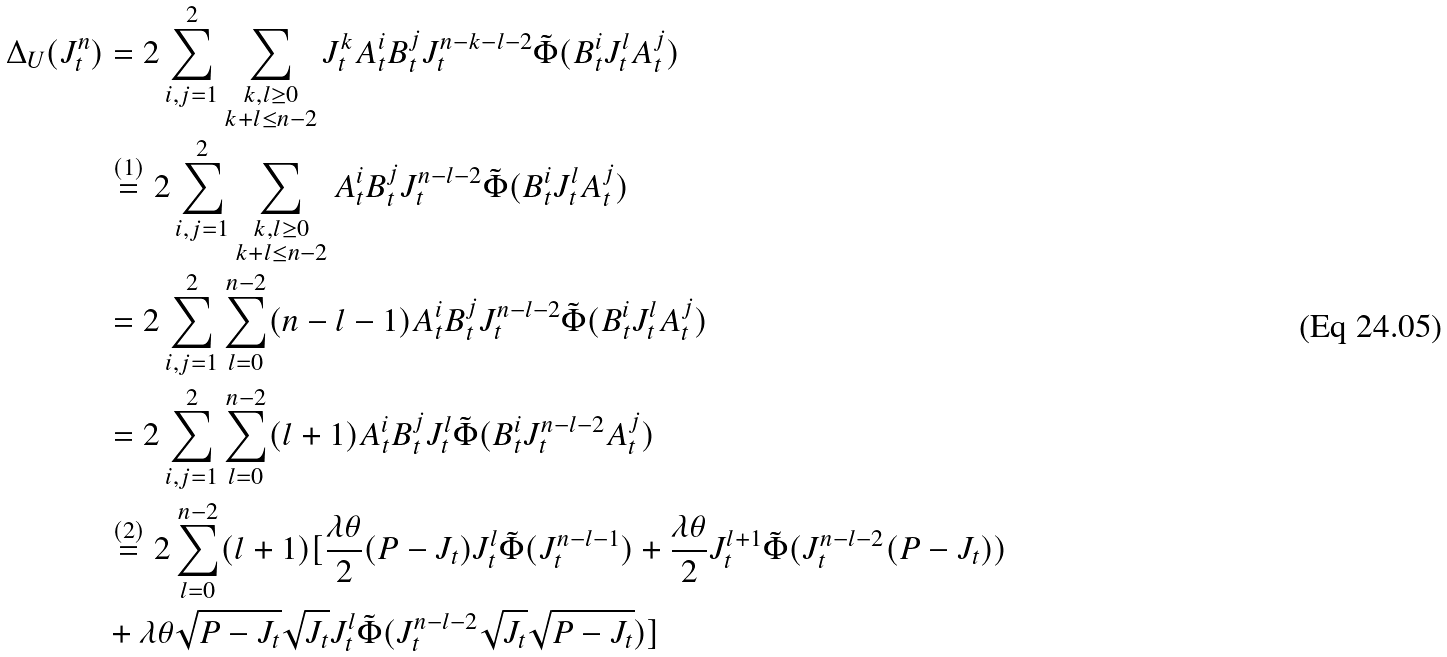<formula> <loc_0><loc_0><loc_500><loc_500>\Delta _ { U } ( J _ { t } ^ { n } ) & = 2 \sum _ { i , j = 1 } ^ { 2 } \sum _ { \substack { k , l \geq 0 \\ k + l \leq n - 2 } } J _ { t } ^ { k } A _ { t } ^ { i } B _ { t } ^ { j } J _ { t } ^ { n - k - l - 2 } \tilde { \Phi } ( B _ { t } ^ { i } J _ { t } ^ { l } A _ { t } ^ { j } ) \\ & \overset { ( 1 ) } { = } 2 \sum _ { i , j = 1 } ^ { 2 } \sum _ { \substack { k , l \geq 0 \\ k + l \leq n - 2 } } A _ { t } ^ { i } B _ { t } ^ { j } J _ { t } ^ { n - l - 2 } \tilde { \Phi } ( B _ { t } ^ { i } J _ { t } ^ { l } A _ { t } ^ { j } ) \\ & = 2 \sum _ { i , j = 1 } ^ { 2 } \sum _ { l = 0 } ^ { n - 2 } ( n - l - 1 ) A _ { t } ^ { i } B _ { t } ^ { j } J _ { t } ^ { n - l - 2 } \tilde { \Phi } ( B _ { t } ^ { i } J _ { t } ^ { l } A _ { t } ^ { j } ) \\ & = 2 \sum _ { i , j = 1 } ^ { 2 } \sum _ { l = 0 } ^ { n - 2 } ( l + 1 ) A _ { t } ^ { i } B _ { t } ^ { j } J _ { t } ^ { l } \tilde { \Phi } ( B _ { t } ^ { i } J _ { t } ^ { n - l - 2 } A _ { t } ^ { j } ) \\ & \overset { ( 2 ) } { = } 2 \sum _ { l = 0 } ^ { n - 2 } ( l + 1 ) [ \frac { \lambda \theta } { 2 } ( P - J _ { t } ) J _ { t } ^ { l } \tilde { \Phi } ( J _ { t } ^ { n - l - 1 } ) + \frac { \lambda \theta } { 2 } J _ { t } ^ { l + 1 } \tilde { \Phi } ( J _ { t } ^ { n - l - 2 } ( P - J _ { t } ) ) \\ & + \lambda \theta \sqrt { P - J _ { t } } \sqrt { J _ { t } } J _ { t } ^ { l } \tilde { \Phi } ( J _ { t } ^ { n - l - 2 } \sqrt { J _ { t } } \sqrt { P - J _ { t } } ) ]</formula> 